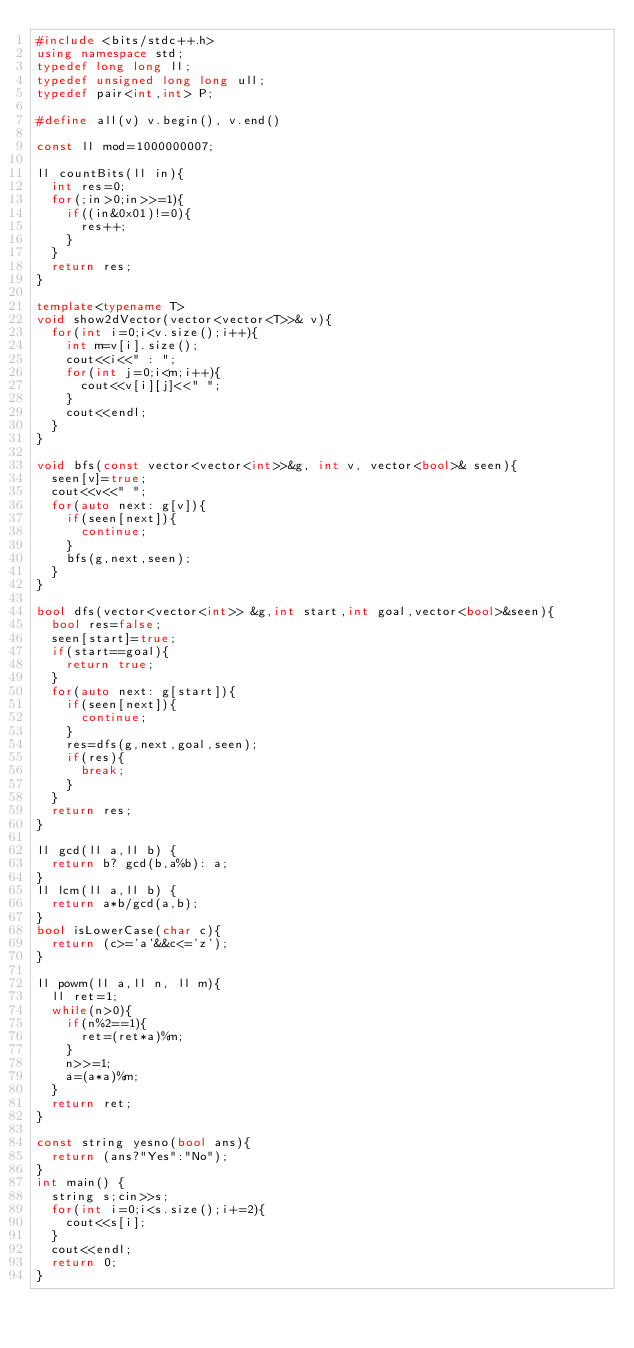<code> <loc_0><loc_0><loc_500><loc_500><_C++_>#include <bits/stdc++.h>
using namespace std;
typedef long long ll;
typedef unsigned long long ull;
typedef pair<int,int> P;

#define all(v) v.begin(), v.end()

const ll mod=1000000007;

ll countBits(ll in){
  int res=0;
  for(;in>0;in>>=1){
    if((in&0x01)!=0){
      res++;
    }
  }
  return res;
}

template<typename T>
void show2dVector(vector<vector<T>>& v){
  for(int i=0;i<v.size();i++){
    int m=v[i].size();
    cout<<i<<" : ";
    for(int j=0;i<m;i++){
      cout<<v[i][j]<<" ";
    }
    cout<<endl;
  }
}

void bfs(const vector<vector<int>>&g, int v, vector<bool>& seen){
  seen[v]=true;
  cout<<v<<" ";
  for(auto next: g[v]){
    if(seen[next]){
      continue;
    }
    bfs(g,next,seen);
  }
}

bool dfs(vector<vector<int>> &g,int start,int goal,vector<bool>&seen){
  bool res=false;
  seen[start]=true;
  if(start==goal){
    return true;
  }
  for(auto next: g[start]){
    if(seen[next]){
      continue;
    }
    res=dfs(g,next,goal,seen);
    if(res){
      break;
    }
  }
  return res;
}

ll gcd(ll a,ll b) {
  return b? gcd(b,a%b): a;  
}
ll lcm(ll a,ll b) {
  return a*b/gcd(a,b);
}
bool isLowerCase(char c){
  return (c>='a'&&c<='z');
}

ll powm(ll a,ll n, ll m){
  ll ret=1;
  while(n>0){
    if(n%2==1){
      ret=(ret*a)%m;
    }
    n>>=1;
    a=(a*a)%m;
  }
  return ret;
}

const string yesno(bool ans){
  return (ans?"Yes":"No");
}
int main() {
  string s;cin>>s;
  for(int i=0;i<s.size();i+=2){
    cout<<s[i];
  }
  cout<<endl;
  return 0;
}
</code> 